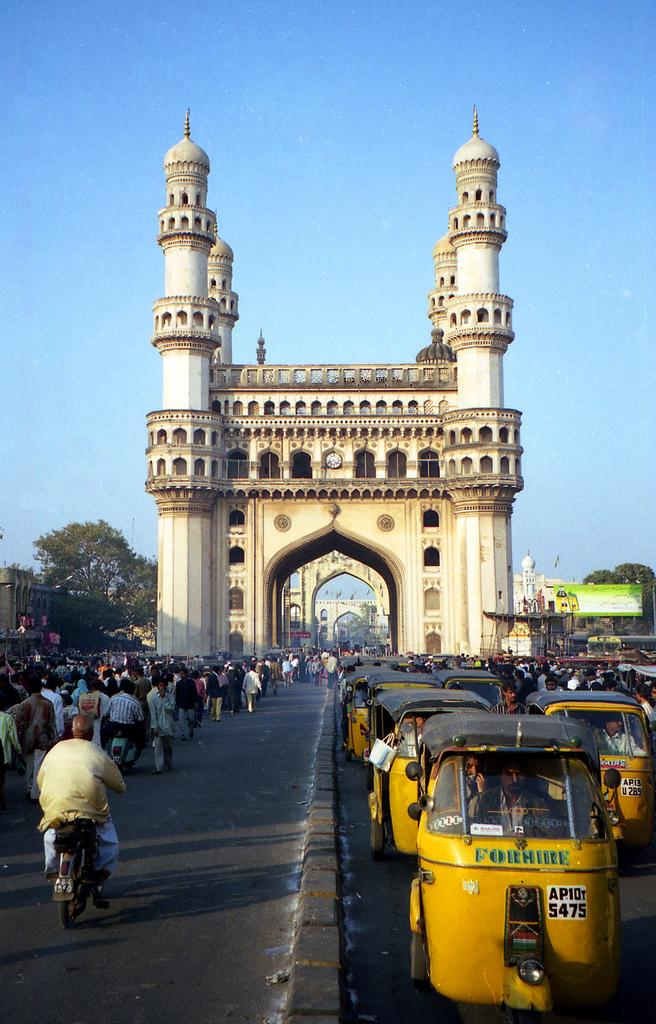Provide a one-sentence caption for the provided image. The little yellow taxis for hire are all lined up. 